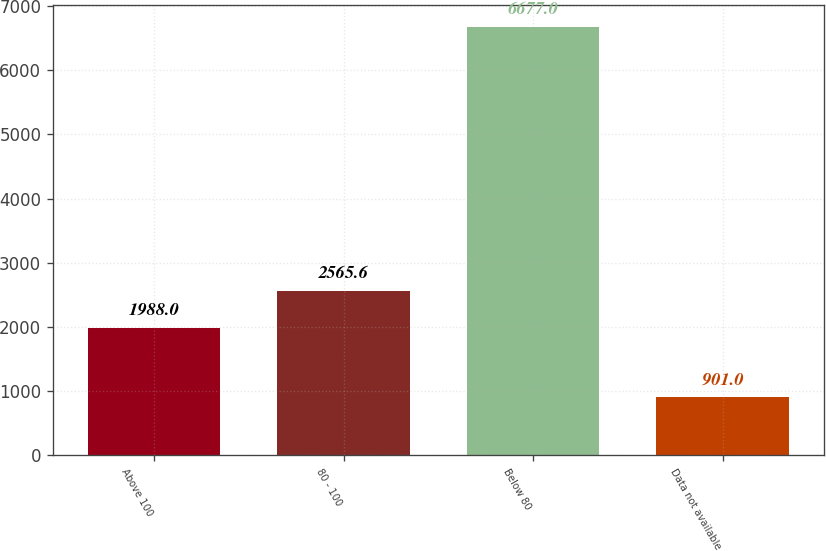<chart> <loc_0><loc_0><loc_500><loc_500><bar_chart><fcel>Above 100<fcel>80 - 100<fcel>Below 80<fcel>Data not available<nl><fcel>1988<fcel>2565.6<fcel>6677<fcel>901<nl></chart> 